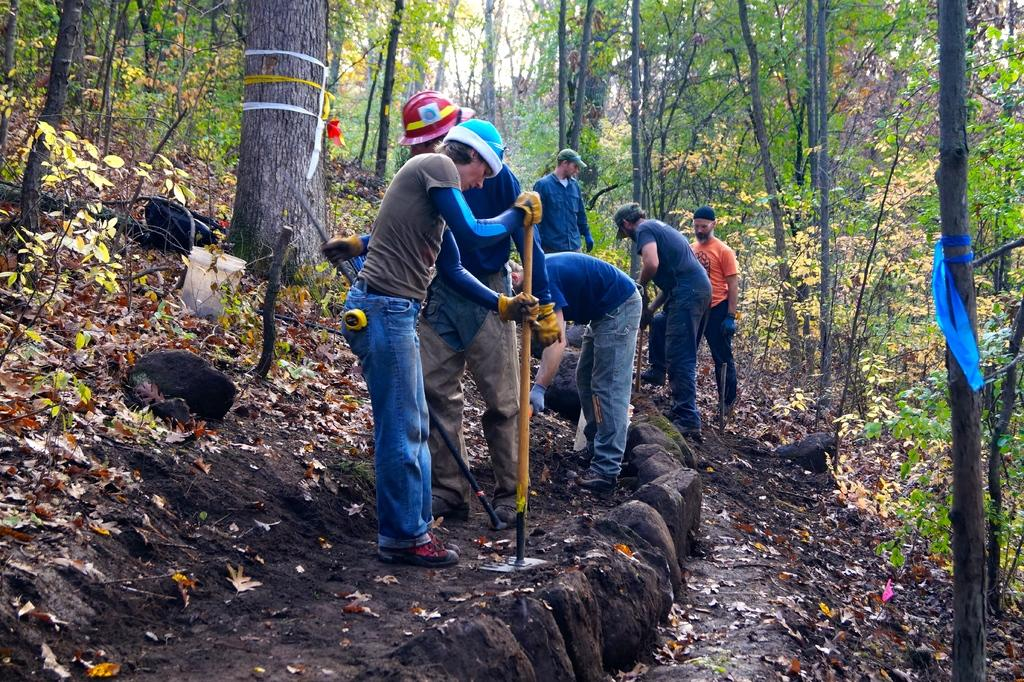What is the main subject of the picture? The main subject of the picture is people. What can be seen on the ground in the image? There are dried leaves on the land. What is visible in the background of the image? There are trees and plants on the ground in the background of the image. What type of health products can be seen in the image? There is no indication of health products in the image; it primarily features people, dried leaves, trees, and plants. 